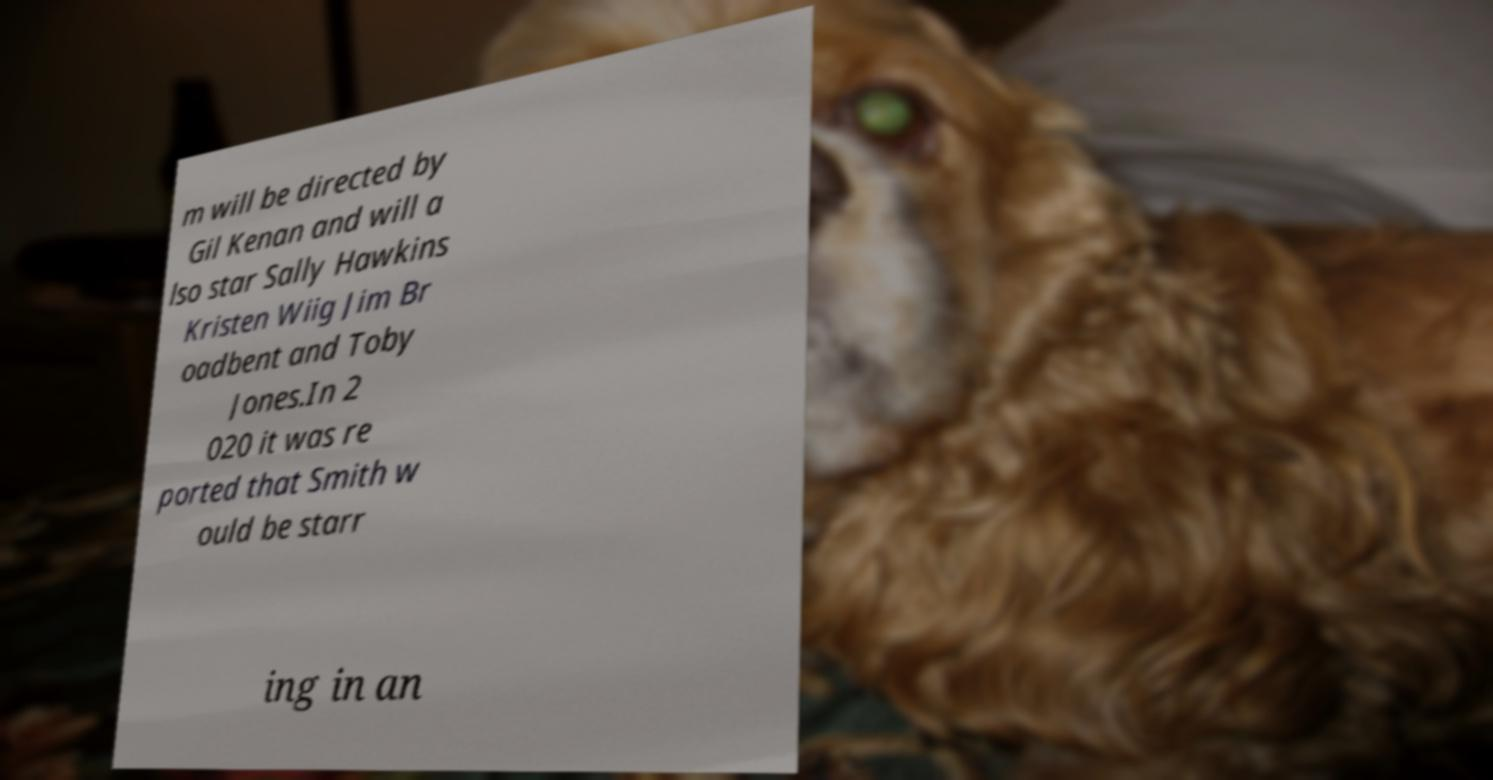Please read and relay the text visible in this image. What does it say? m will be directed by Gil Kenan and will a lso star Sally Hawkins Kristen Wiig Jim Br oadbent and Toby Jones.In 2 020 it was re ported that Smith w ould be starr ing in an 